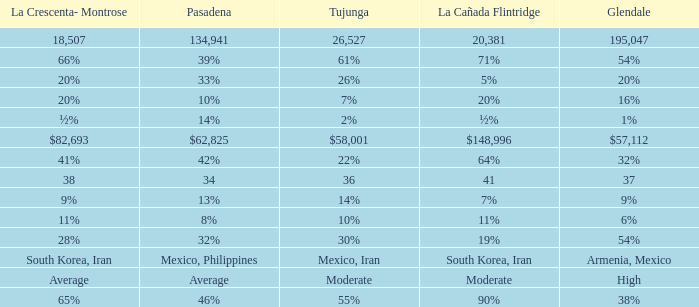What is the figure for Tujunga when Pasadena is 134,941? 26527.0. 